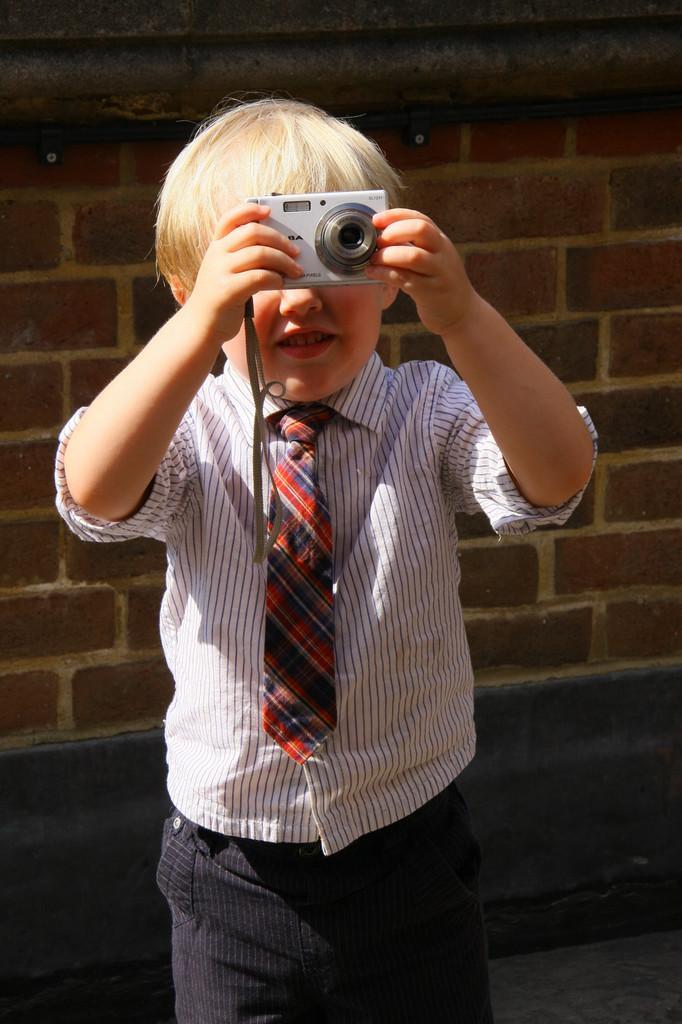Please provide a concise description of this image. In this Picture we can see that a small boy wearing school dress of white and black stripe shirt with red tie , holding a camera in the hand and taking photo. 